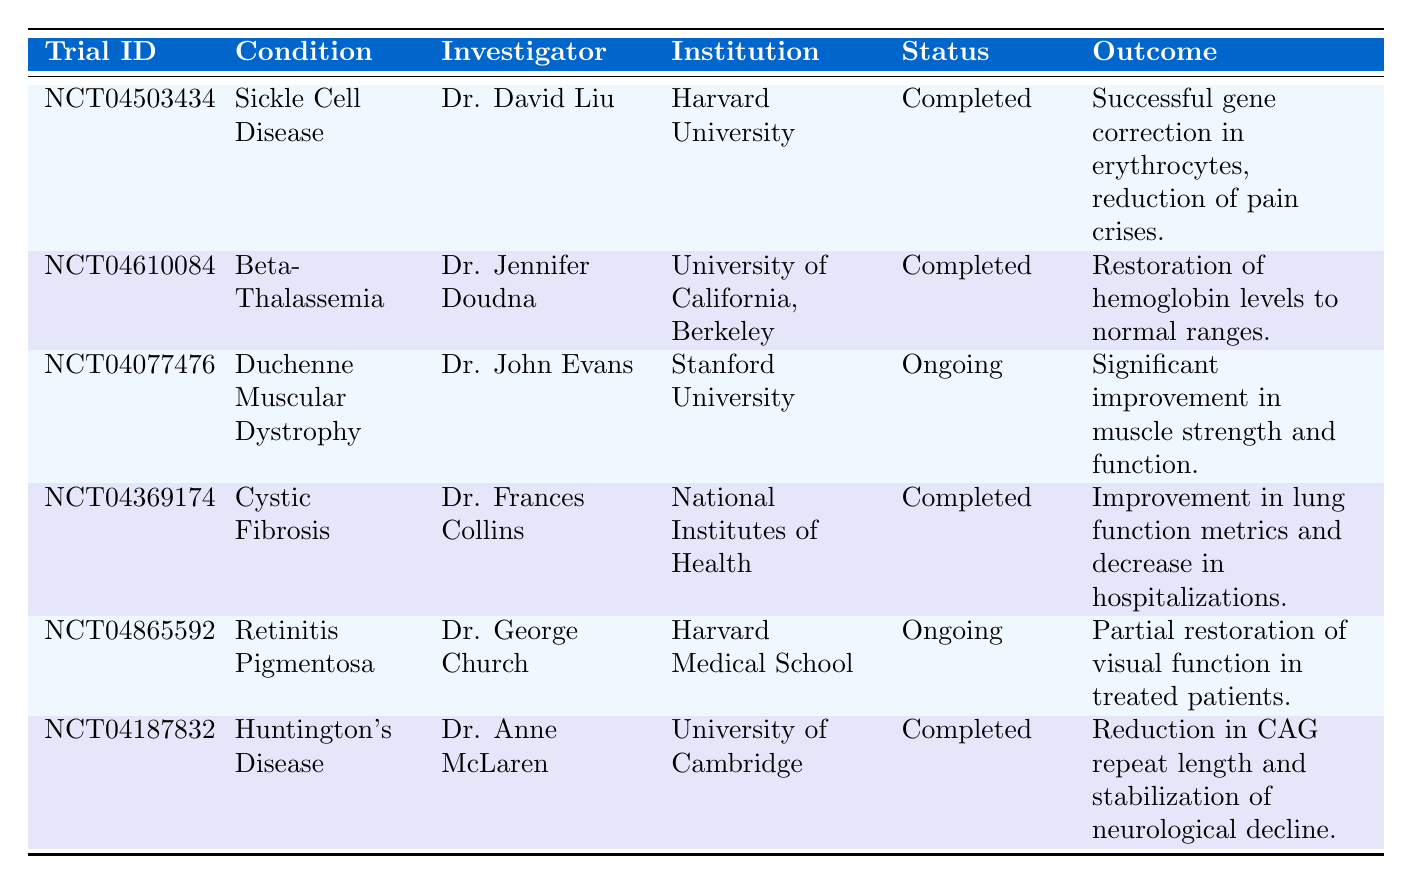What is the condition associated with trial ID NCT04503434? The trial ID NCT04503434 corresponds to the condition named Sickle Cell Disease, which can be found in the "Condition" column.
Answer: Sickle Cell Disease Who is the investigator for the trial studying Beta-Thalassemia? The investigator for the trial studying Beta-Thalassemia is Dr. Jennifer Doudna, which is listed in the "Investigator" column for the respective condition.
Answer: Dr. Jennifer Doudna How many trials are ongoing? There are 2 ongoing trials: Duchenne Muscular Dystrophy and Retinitis Pigmentosa. The "Status" column indicates the ongoing trials.
Answer: 2 Did Dr. Anne McLaren investigate a trial for confirmation of gene editing effects on Huntington's Disease? Yes, Dr. Anne McLaren is listed as the investigator for the Huntington's Disease trial, confirming that this trial is indeed investigating the effects of gene editing on this condition.
Answer: Yes What is the outcome reported for the trial related to Cystic Fibrosis? The outcome reported for the trial related to Cystic Fibrosis is an improvement in lung function metrics and a decrease in hospitalizations as noted in the "Outcome" column.
Answer: Improvement in lung function metrics and decrease in hospitalizations What is the age range of participants involved in the trial led by Dr. George Church? The age range of participants involved in the trial led by Dr. George Church is 18-40 years old, which can be found in the "Age Range" column of the table.
Answer: 18-40 Which institution conducted a trial for Sickle Cell Disease, and what is the publication source? The trial for Sickle Cell Disease was conducted by Harvard University, and the publication source is Nature Medicine, 2023, both of which can be confirmed from the respective columns.
Answer: Harvard University; Nature Medicine, 2023 What age range is applicable for trials related to Duchenne Muscular Dystrophy? The age range applicable for the Duchenne Muscular Dystrophy trial is 5-15 years, as specified in the "Age Range" column.
Answer: 5-15 Calculate the total number of completed trials. There are 4 completed trials: Sickle Cell Disease, Beta-Thalassemia, Cystic Fibrosis, and Huntington's Disease. Adding these gives us a total of 4 completed trials.
Answer: 4 